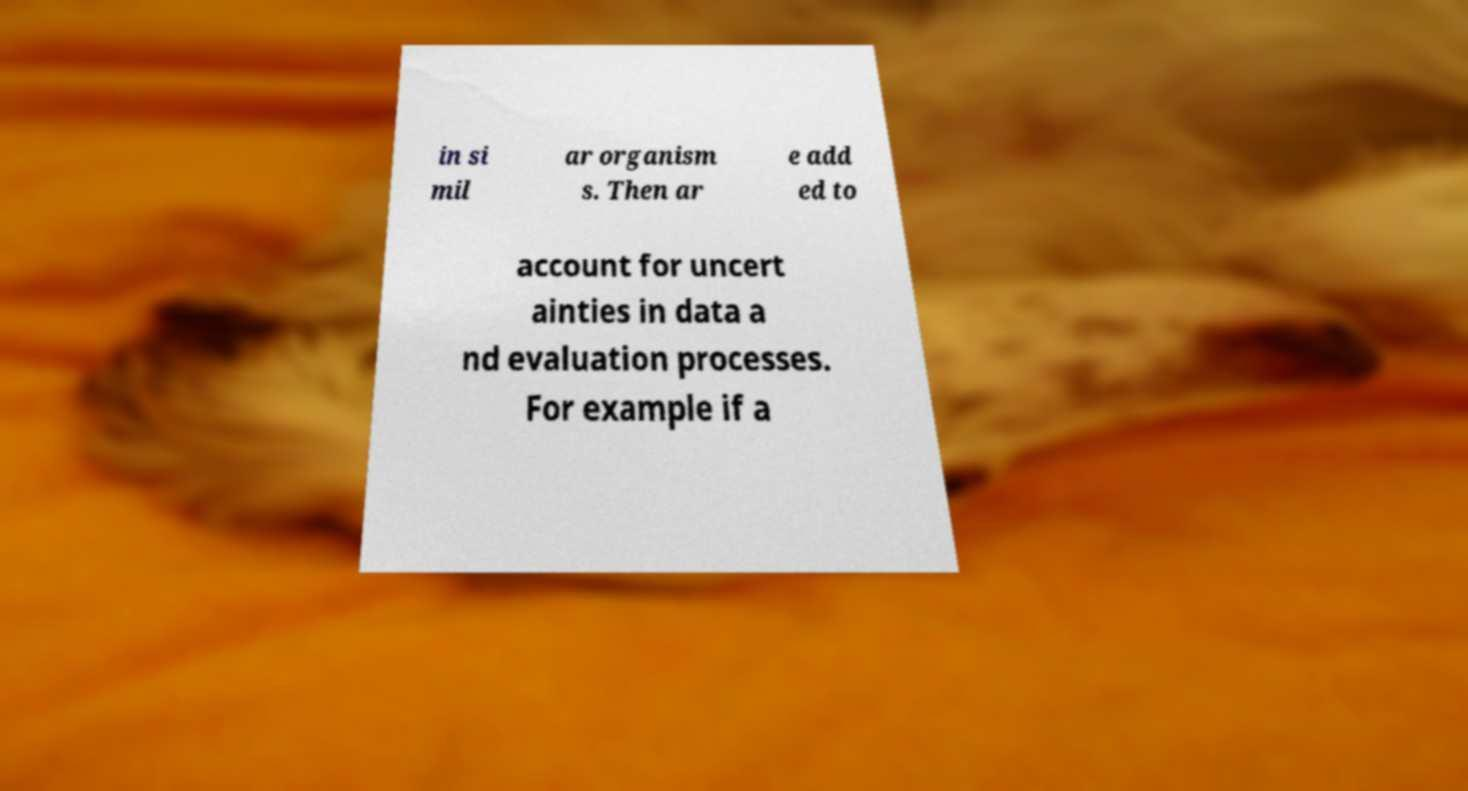Could you assist in decoding the text presented in this image and type it out clearly? in si mil ar organism s. Then ar e add ed to account for uncert ainties in data a nd evaluation processes. For example if a 